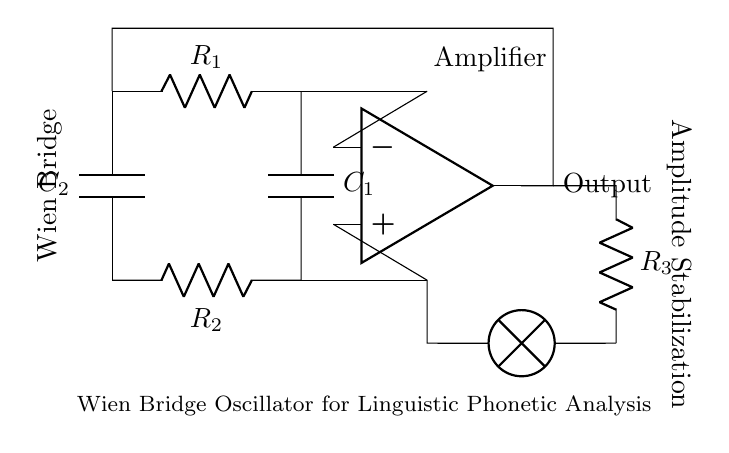What is the type of oscillator shown in the circuit? The circuit is identified as a Wien Bridge oscillator due to its characteristic configuration, which includes resistors and capacitors arranged to provide frequency stability through positive and negative feedback.
Answer: Wien Bridge How many resistors are present in this circuit? There are three resistors in the circuit: R1, R2, and R3. R1 and R2 are part of the Wien Bridge configuration while R3 is used for amplitude stabilization.
Answer: Three What role does the amplifier play in this circuit? The amplifier, depicted in the circuit as an op-amp, serves to amplify the oscillation signal generated by the Wien Bridge, allowing the circuit to produce a larger output signal essential for driving the phonetic analysis equipment effectively.
Answer: Amplification Which component is primarily responsible for frequency determination in the circuit? The frequency is primarily determined by the resistor-capacitor pairs R1, R2 with C1, and C2 since their values set the oscillation frequency through the formula for the Wien Bridge oscillator.
Answer: Resistor-Capacitor pairs Why is amplitude stabilization necessary in this circuit? Amplitude stabilization is essential because it prevents oscillations from growing too large or decaying, ensuring a consistent output signal which is crucial for accurate phonetic measurements. This is achieved via the resistor R3 and the connected lamp that provides feedback for stabilization.
Answer: Consistent output What is the output of the Wien Bridge oscillator designated as in the circuit? The output is designated at the point following the amplifier, indicating the circuit’s output signal that can be used for further analysis.
Answer: Output 